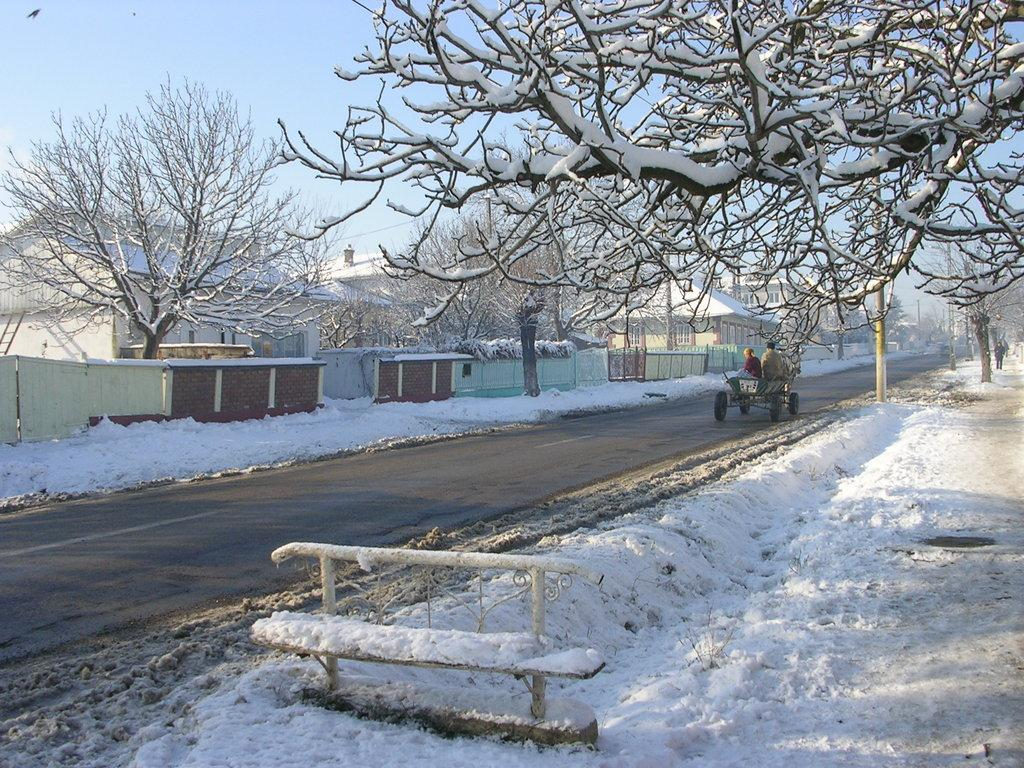What type of structures can be seen in the image? There are buildings in the image. What feature is common to many of the buildings? The image contains windows. What type of vegetation is present in the image? Dry trees are present in the image. What weather condition is depicted in the image? There is snow visible in the image. What type of outdoor furniture is in the image? A bench is in the image. What type of vertical structures are in the image? Poles are in the image. What activity are people engaged in within the image? There are people sitting on a vehicle in the image. What color is the sky in the image? The sky is blue in the image. What type of oatmeal is being served on the bench in the image? There is no oatmeal present in the image; it features buildings, windows, dry trees, snow, a bench, poles, people sitting on a vehicle, and a blue sky. What type of rod is being used to shake the snow off the dry trees in the image? There is no rod or shaking of snow off the dry trees depicted in the image. 